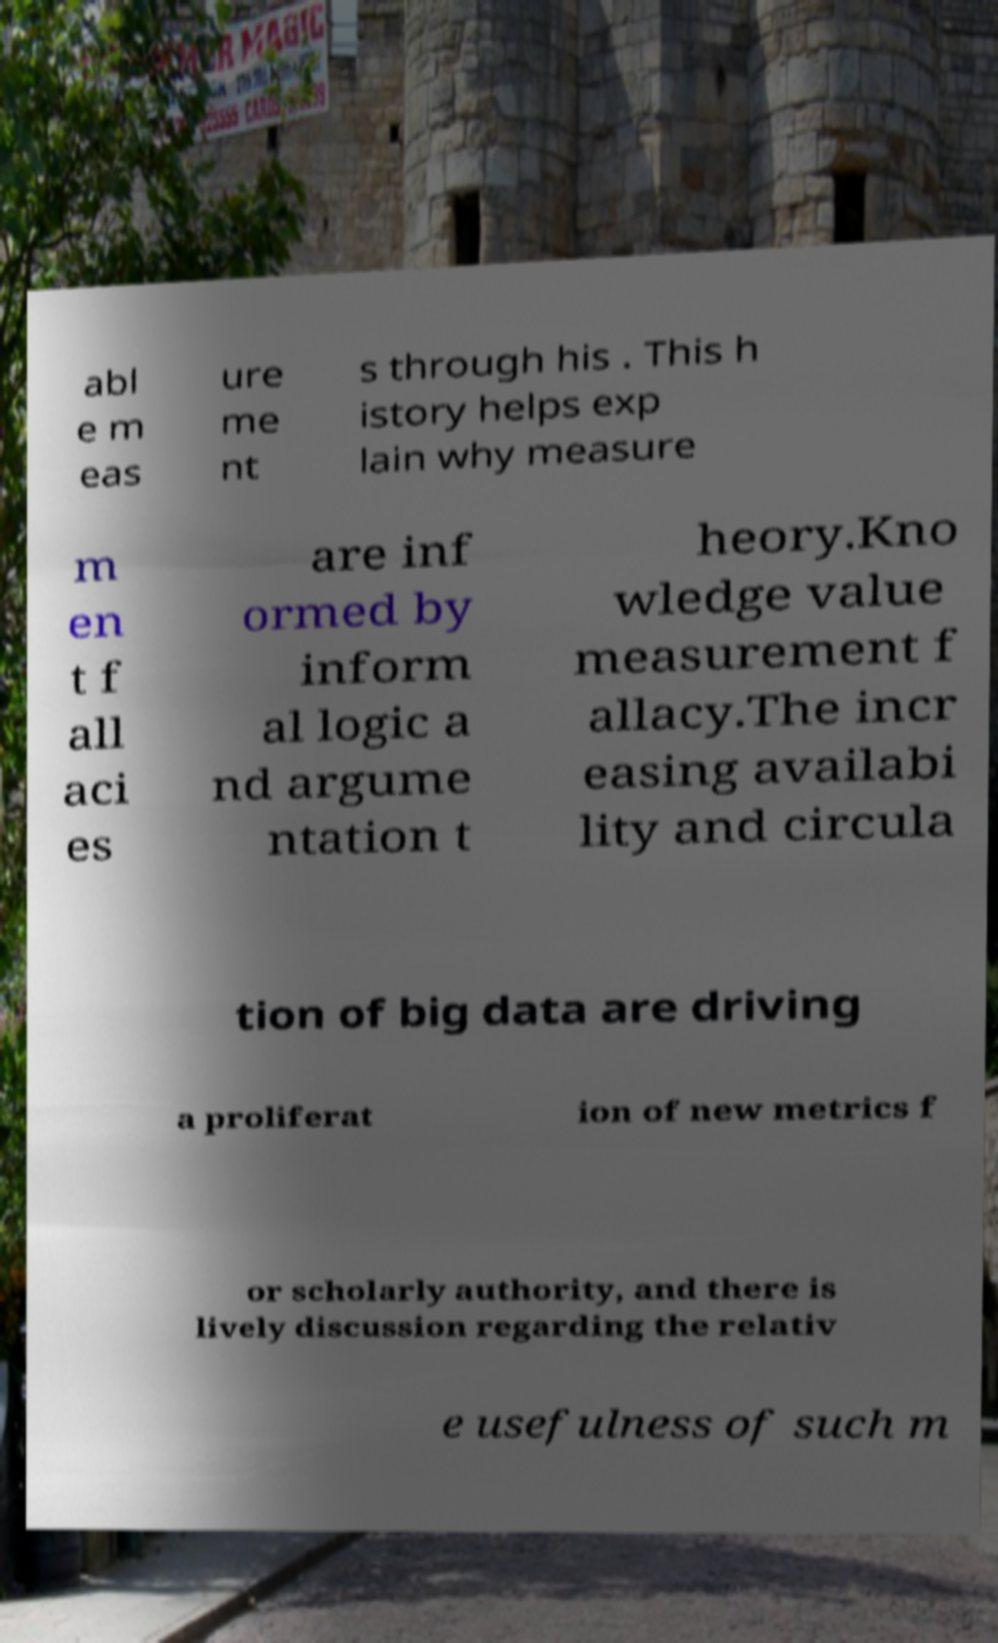Please identify and transcribe the text found in this image. abl e m eas ure me nt s through his . This h istory helps exp lain why measure m en t f all aci es are inf ormed by inform al logic a nd argume ntation t heory.Kno wledge value measurement f allacy.The incr easing availabi lity and circula tion of big data are driving a proliferat ion of new metrics f or scholarly authority, and there is lively discussion regarding the relativ e usefulness of such m 